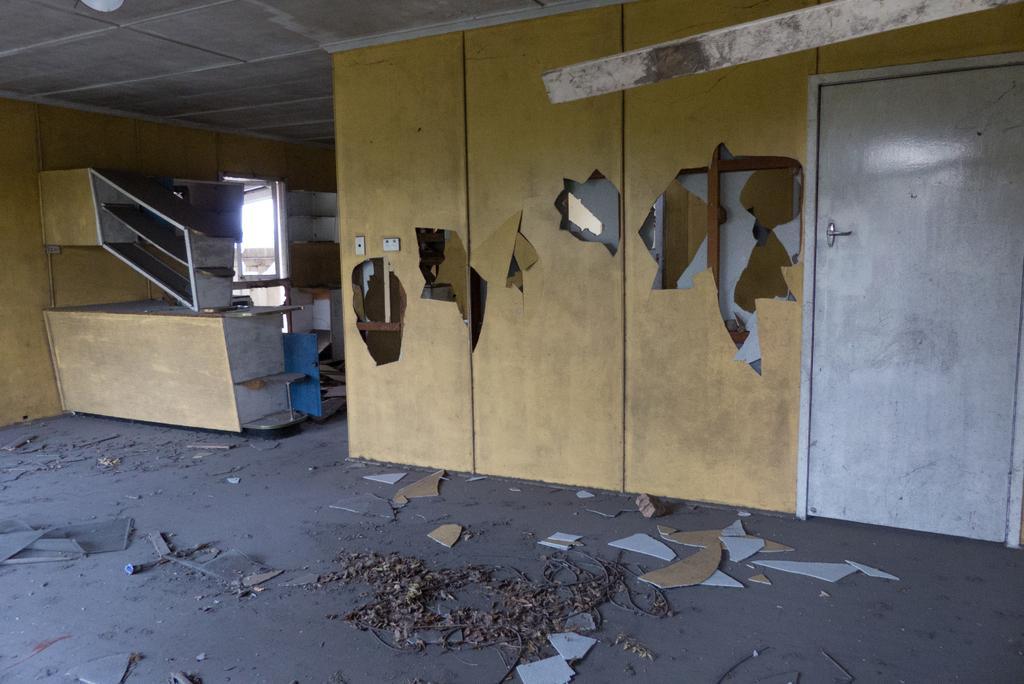Please provide a concise description of this image. This is a picture of a room, in this image there is a wall, door and on the wall there are some holes, and on the left side there is a table, wooden boards and some racks, wall and some other objects. At the bottom there is floor and on the floor there is some scrap, and at the top there is ceiling. 